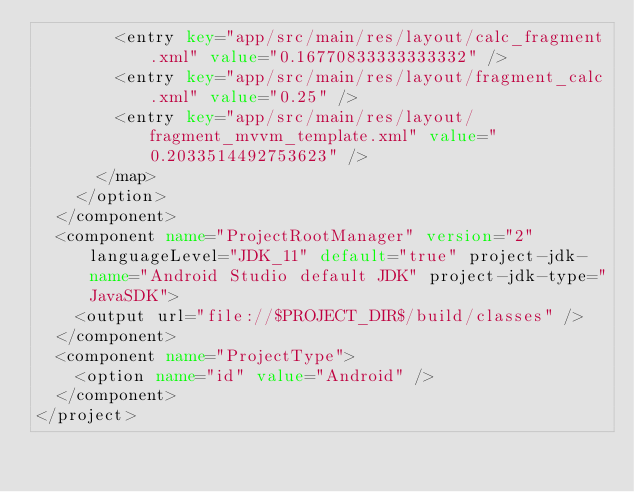<code> <loc_0><loc_0><loc_500><loc_500><_XML_>        <entry key="app/src/main/res/layout/calc_fragment.xml" value="0.16770833333333332" />
        <entry key="app/src/main/res/layout/fragment_calc.xml" value="0.25" />
        <entry key="app/src/main/res/layout/fragment_mvvm_template.xml" value="0.2033514492753623" />
      </map>
    </option>
  </component>
  <component name="ProjectRootManager" version="2" languageLevel="JDK_11" default="true" project-jdk-name="Android Studio default JDK" project-jdk-type="JavaSDK">
    <output url="file://$PROJECT_DIR$/build/classes" />
  </component>
  <component name="ProjectType">
    <option name="id" value="Android" />
  </component>
</project></code> 